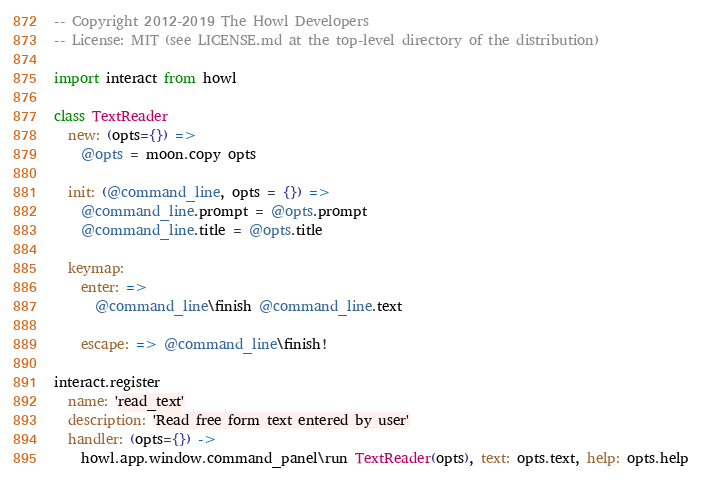<code> <loc_0><loc_0><loc_500><loc_500><_MoonScript_>-- Copyright 2012-2019 The Howl Developers
-- License: MIT (see LICENSE.md at the top-level directory of the distribution)

import interact from howl

class TextReader
  new: (opts={}) =>
    @opts = moon.copy opts

  init: (@command_line, opts = {}) =>
    @command_line.prompt = @opts.prompt
    @command_line.title = @opts.title

  keymap:
    enter: =>
      @command_line\finish @command_line.text

    escape: => @command_line\finish!

interact.register
  name: 'read_text'
  description: 'Read free form text entered by user'
  handler: (opts={}) ->
    howl.app.window.command_panel\run TextReader(opts), text: opts.text, help: opts.help
</code> 